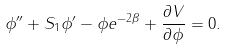<formula> <loc_0><loc_0><loc_500><loc_500>\phi ^ { \prime \prime } + S _ { 1 } \phi ^ { \prime } - \phi e ^ { - 2 \beta } + \frac { \partial V } { \partial \phi } = 0 .</formula> 